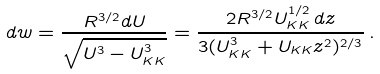<formula> <loc_0><loc_0><loc_500><loc_500>d w = \frac { R ^ { 3 / 2 } d U } { \sqrt { U ^ { 3 } - U _ { K K } ^ { 3 } } } = \frac { 2 R ^ { 3 / 2 } U _ { K K } ^ { 1 / 2 } \, d z } { 3 ( U _ { K K } ^ { 3 } + U _ { K K } z ^ { 2 } ) ^ { 2 / 3 } } \, .</formula> 